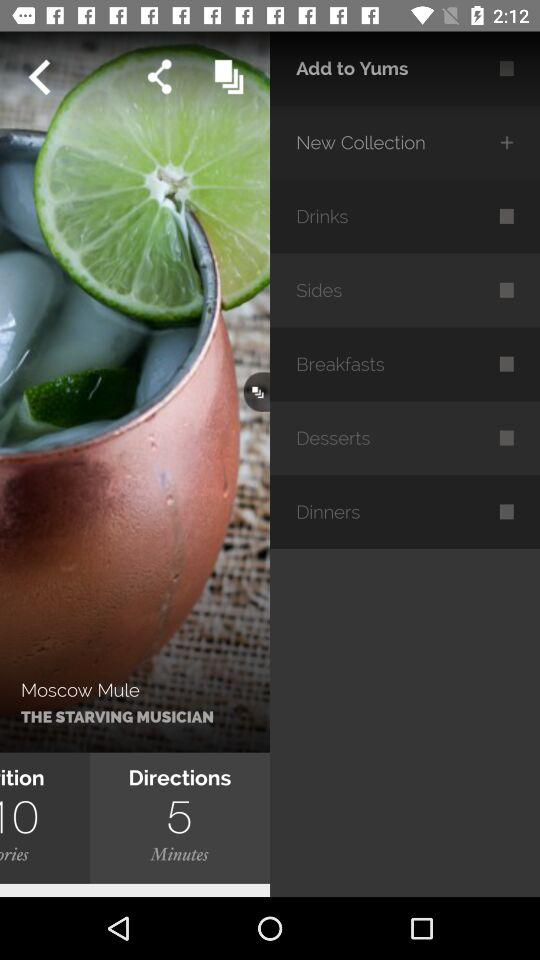What is the name of the drink? The name of the drink is "Moscow Mule". 